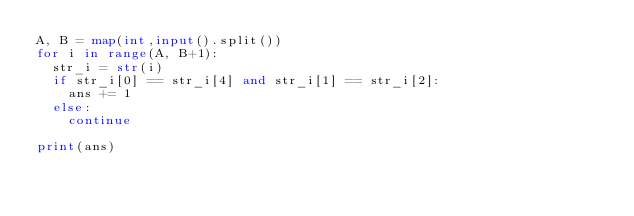Convert code to text. <code><loc_0><loc_0><loc_500><loc_500><_Python_>A, B = map(int,input().split())
for i in range(A, B+1):
  str_i = str(i)
  if str_i[0] == str_i[4] and str_i[1] == str_i[2]:
    ans += 1
  else:
    continue

print(ans)</code> 